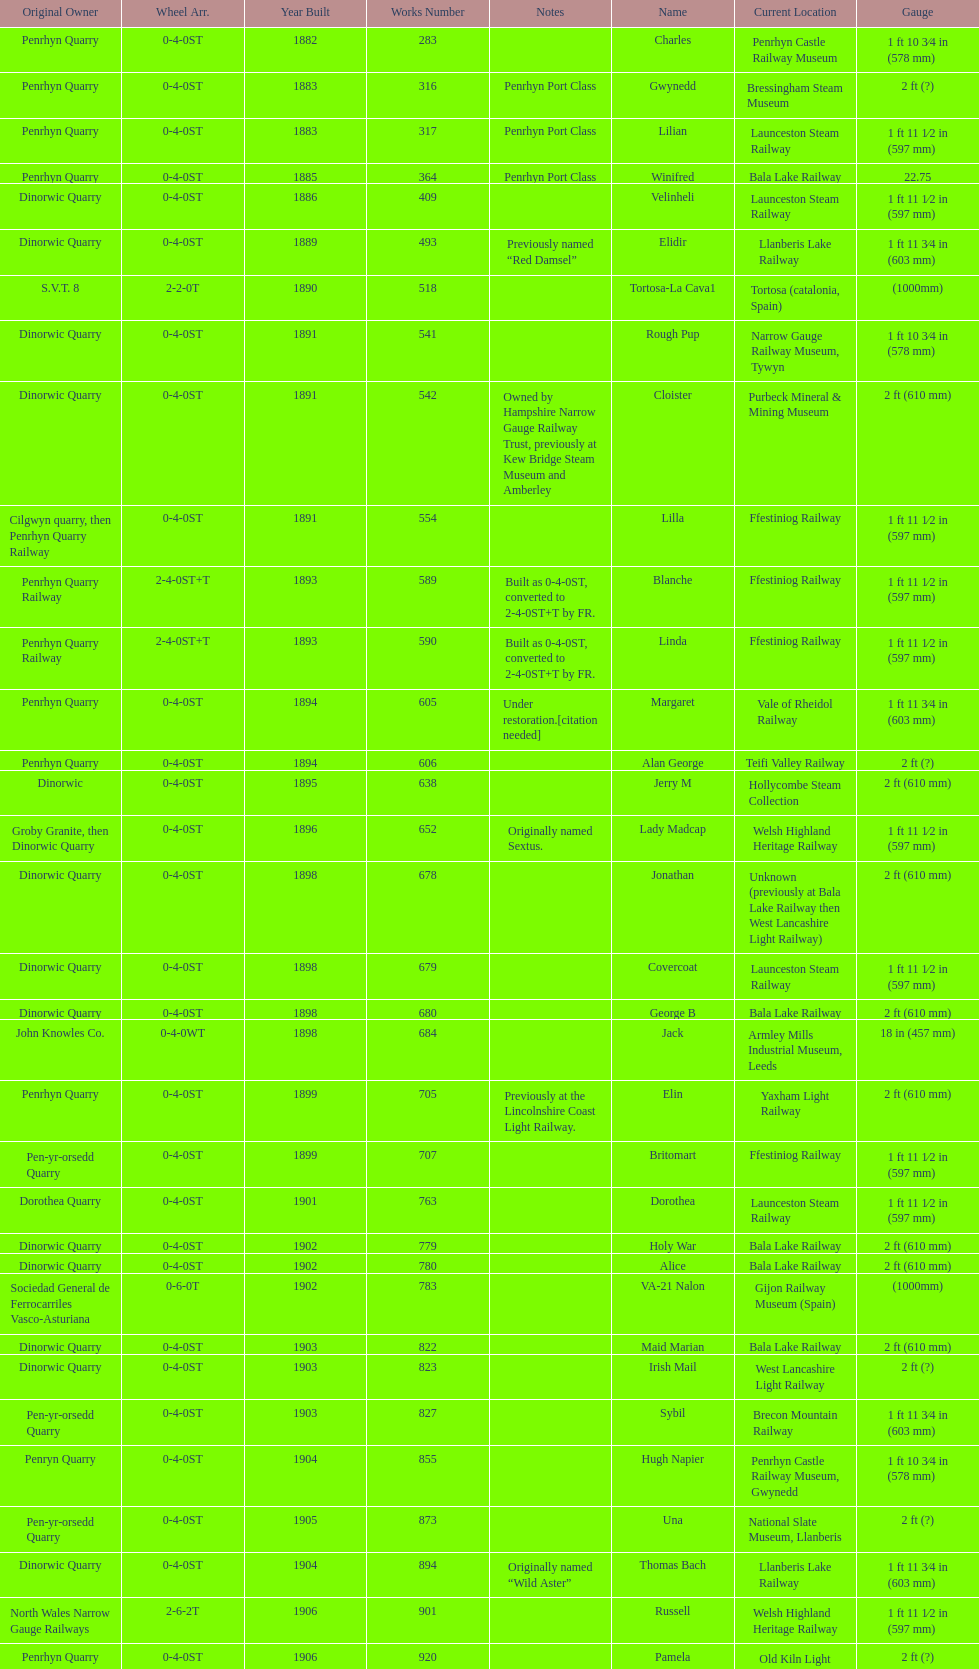In which year were the most steam locomotives built? 1898. 